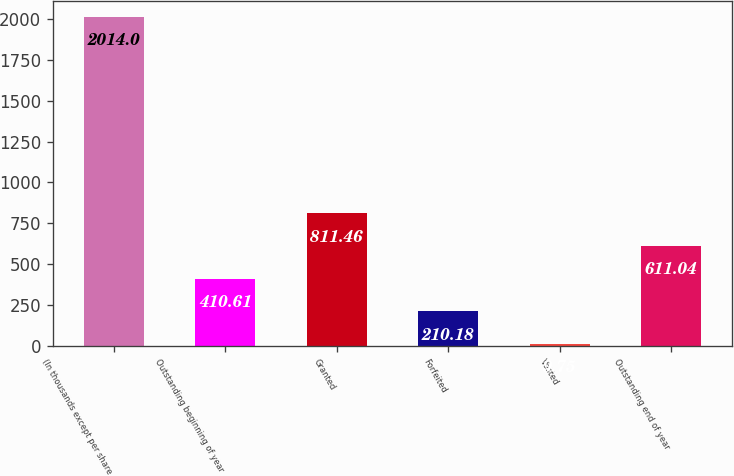<chart> <loc_0><loc_0><loc_500><loc_500><bar_chart><fcel>(In thousands except per share<fcel>Outstanding beginning of year<fcel>Granted<fcel>Forfeited<fcel>Vested<fcel>Outstanding end of year<nl><fcel>2014<fcel>410.61<fcel>811.46<fcel>210.18<fcel>9.75<fcel>611.04<nl></chart> 